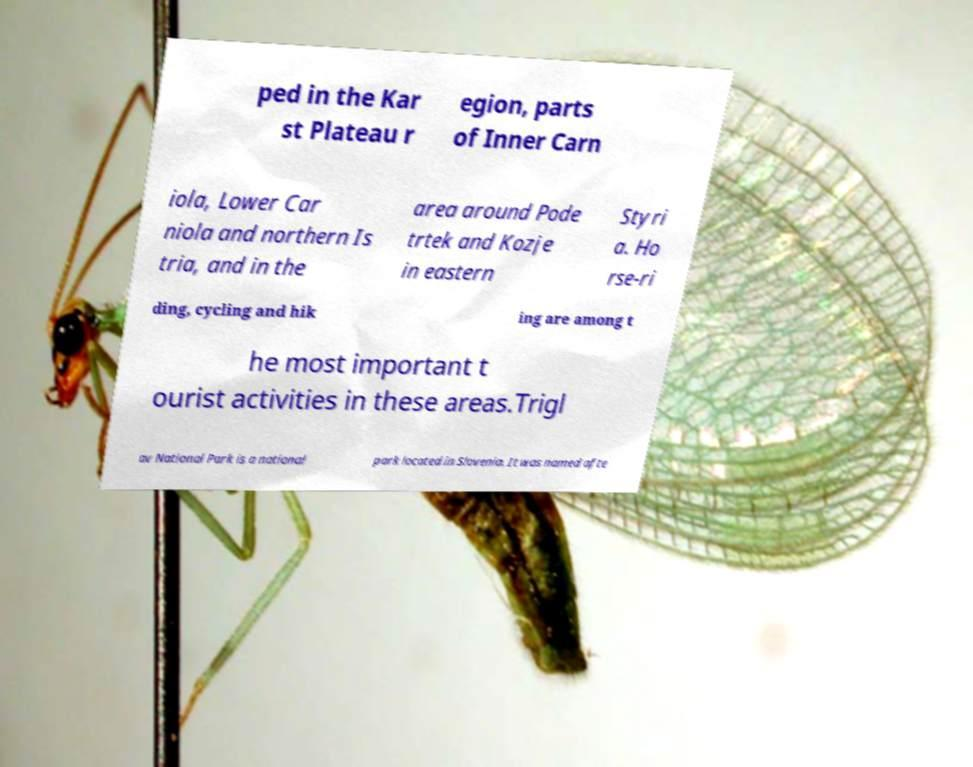Can you accurately transcribe the text from the provided image for me? ped in the Kar st Plateau r egion, parts of Inner Carn iola, Lower Car niola and northern Is tria, and in the area around Pode trtek and Kozje in eastern Styri a. Ho rse-ri ding, cycling and hik ing are among t he most important t ourist activities in these areas.Trigl av National Park is a national park located in Slovenia. It was named afte 